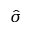<formula> <loc_0><loc_0><loc_500><loc_500>\hat { \sigma }</formula> 